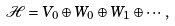<formula> <loc_0><loc_0><loc_500><loc_500>\mathcal { H } = V _ { 0 } \oplus W _ { 0 } \oplus W _ { 1 } \oplus \cdots ,</formula> 